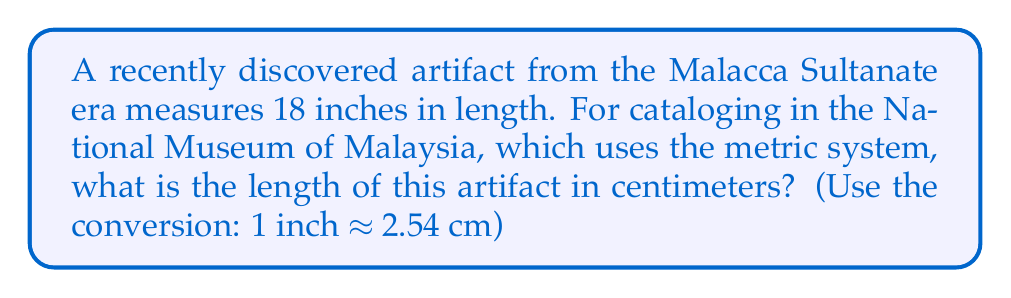Teach me how to tackle this problem. To convert the length of the artifact from inches to centimeters, we need to multiply the given length by the conversion factor:

1. Given: 
   - Artifact length = 18 inches
   - Conversion factor: 1 inch ≈ 2.54 cm

2. Set up the conversion:
   $$ \text{Length in cm} = 18 \text{ inches} \times \frac{2.54 \text{ cm}}{1 \text{ inch}} $$

3. Multiply:
   $$ \text{Length in cm} = 18 \times 2.54 = 45.72 \text{ cm} $$

4. Round to the nearest tenth (as this level of precision is usually sufficient for historical artifacts):
   $$ \text{Length in cm} \approx 45.7 \text{ cm} $$

Thus, the artifact measures approximately 45.7 cm in length.
Answer: 45.7 cm 